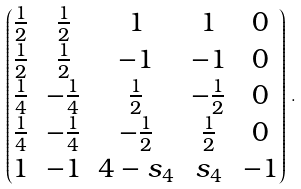<formula> <loc_0><loc_0><loc_500><loc_500>\begin{pmatrix} \frac { 1 } { 2 } & \frac { 1 } { 2 } & 1 & 1 & 0 \\ \frac { 1 } { 2 } & \frac { 1 } { 2 } & - 1 & - 1 & 0 \\ \frac { 1 } { 4 } & - \frac { 1 } { 4 } & \frac { 1 } { 2 } & - \frac { 1 } { 2 } & 0 \\ \frac { 1 } { 4 } & - \frac { 1 } { 4 } & - \frac { 1 } { 2 } & \frac { 1 } { 2 } & 0 \\ 1 & - 1 & 4 - s _ { 4 } & s _ { 4 } & - 1 \end{pmatrix} \, .</formula> 